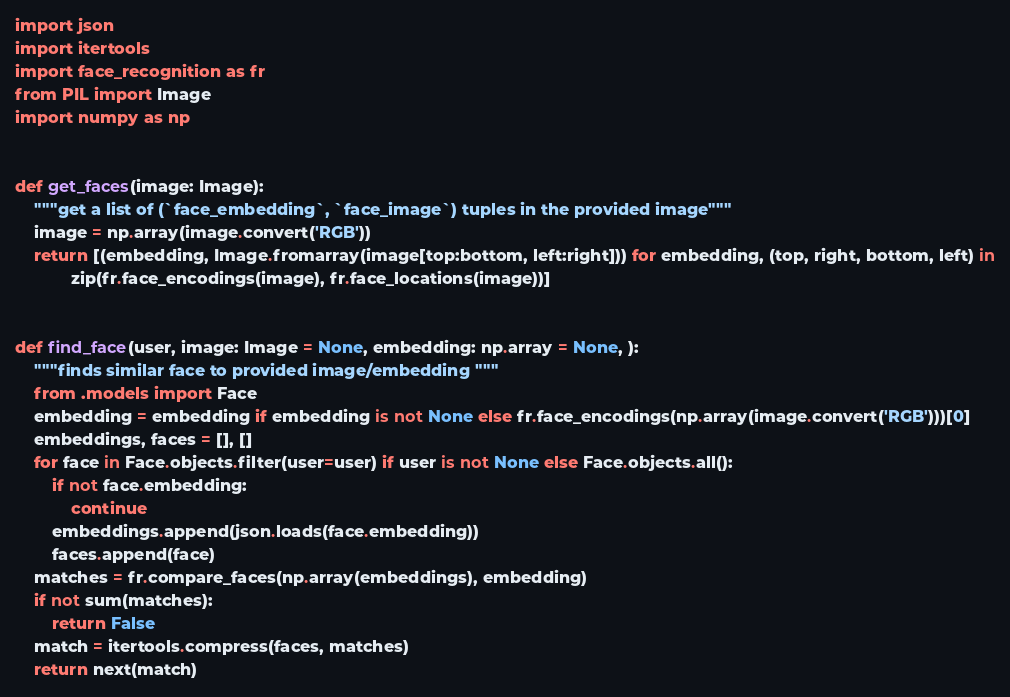<code> <loc_0><loc_0><loc_500><loc_500><_Python_>import json
import itertools
import face_recognition as fr
from PIL import Image
import numpy as np


def get_faces(image: Image):
    """get a list of (`face_embedding`, `face_image`) tuples in the provided image"""
    image = np.array(image.convert('RGB'))
    return [(embedding, Image.fromarray(image[top:bottom, left:right])) for embedding, (top, right, bottom, left) in
            zip(fr.face_encodings(image), fr.face_locations(image))]


def find_face(user, image: Image = None, embedding: np.array = None, ):
    """finds similar face to provided image/embedding """
    from .models import Face
    embedding = embedding if embedding is not None else fr.face_encodings(np.array(image.convert('RGB')))[0]
    embeddings, faces = [], []
    for face in Face.objects.filter(user=user) if user is not None else Face.objects.all():
        if not face.embedding:
            continue
        embeddings.append(json.loads(face.embedding))
        faces.append(face)
    matches = fr.compare_faces(np.array(embeddings), embedding)
    if not sum(matches):
        return False
    match = itertools.compress(faces, matches)
    return next(match)
</code> 